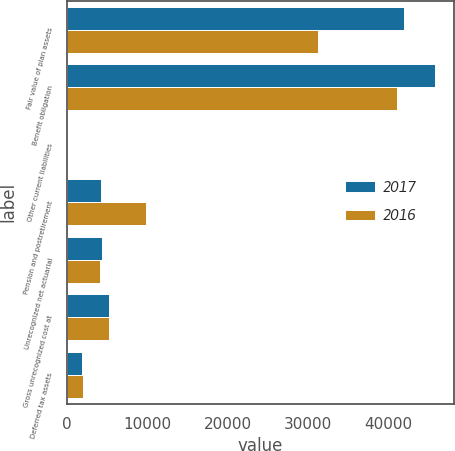Convert chart. <chart><loc_0><loc_0><loc_500><loc_500><stacked_bar_chart><ecel><fcel>Fair value of plan assets<fcel>Benefit obligation<fcel>Other current liabilities<fcel>Pension and postretirement<fcel>Unrecognized net actuarial<fcel>Gross unrecognized cost at<fcel>Deferred tax assets<nl><fcel>2017<fcel>41932<fcel>45847<fcel>18<fcel>4181<fcel>4277<fcel>5157<fcel>1840<nl><fcel>2016<fcel>31215<fcel>41069<fcel>17<fcel>9837<fcel>4107<fcel>5181<fcel>1948<nl></chart> 